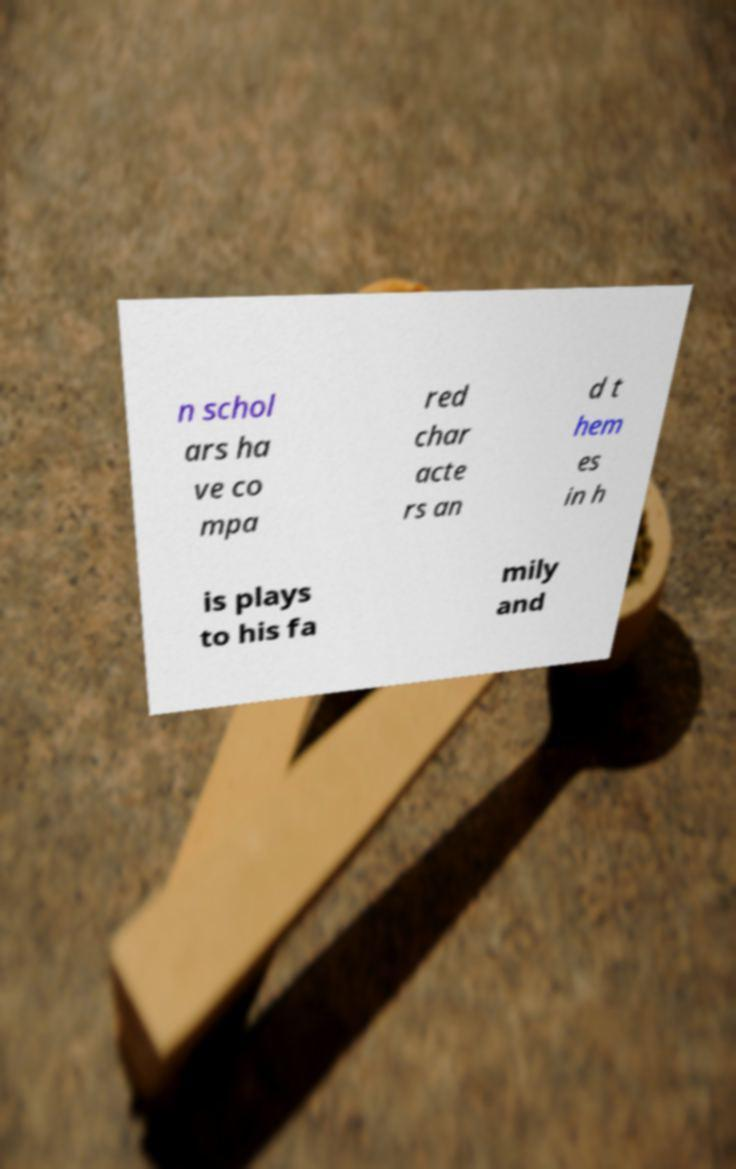What messages or text are displayed in this image? I need them in a readable, typed format. n schol ars ha ve co mpa red char acte rs an d t hem es in h is plays to his fa mily and 